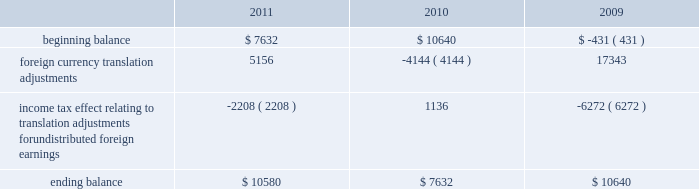The table sets forth the components of foreign currency translation adjustments for fiscal 2011 , 2010 and 2009 ( in thousands ) : beginning balance foreign currency translation adjustments income tax effect relating to translation adjustments for undistributed foreign earnings ending balance $ 7632 ( 2208 ) $ 10580 $ 10640 ( 4144 ) $ 7632 $ ( 431 ) 17343 ( 6272 ) $ 10640 stock repurchase program to facilitate our stock repurchase program , designed to return value to our stockholders and minimize dilution from stock issuances , we repurchase shares in the open market and also enter into structured repurchase agreements with third-parties .
Authorization to repurchase shares to cover on-going dilution was not subject to expiration .
However , this repurchase program was limited to covering net dilution from stock issuances and was subject to business conditions and cash flow requirements as determined by our board of directors from time to time .
During the third quarter of fiscal 2010 , our board of directors approved an amendment to our stock repurchase program authorized in april 2007 from a non-expiring share-based authority to a time-constrained dollar-based authority .
As part of this amendment , the board of directors granted authority to repurchase up to $ 1.6 billion in common stock through the end of fiscal 2012 .
This amended program did not affect the $ 250.0 million structured stock repurchase agreement entered into during march 2010 .
As of december 3 , 2010 , no prepayments remain under that agreement .
During fiscal 2011 , 2010 and 2009 , we entered into several structured repurchase agreements with large financial institutions , whereupon we provided the financial institutions with prepayments totaling $ 695.0 million , $ 850.0 million and $ 350.0 million , respectively .
Of the $ 850.0 million of prepayments during fiscal 2010 , $ 250.0 million was under the stock repurchase program prior to the program amendment and the remaining $ 600.0 million was under the amended $ 1.6 billion time-constrained dollar- based authority .
We enter into these agreements in order to take advantage of repurchasing shares at a guaranteed discount to the volume weighted average price ( 201cvwap 201d ) of our common stock over a specified period of time .
We only enter into such transactions when the discount that we receive is higher than the foregone return on our cash prepayments to the financial institutions .
There were no explicit commissions or fees on these structured repurchases .
Under the terms of the agreements , there is no requirement for the financial institutions to return any portion of the prepayment to us .
The financial institutions agree to deliver shares to us at monthly intervals during the contract term .
The parameters used to calculate the number of shares deliverable are : the total notional amount of the contract , the number of trading days in the contract , the number of trading days in the interval and the average vwap of our stock during the interval less the agreed upon discount .
During fiscal 2011 , we repurchased approximately 21.8 million shares at an average price of $ 31.81 through structured repurchase agreements entered into during fiscal 2011 .
During fiscal 2010 , we repurchased approximately 31.2 million shares at an average price of $ 29.19 through structured repurchase agreements entered into during fiscal 2009 and fiscal 2010 .
During fiscal 2009 , we repurchased approximately 15.2 million shares at an average price per share of $ 27.89 through structured repurchase agreements entered into during fiscal 2008 and fiscal 2009 .
For fiscal 2011 , 2010 and 2009 , the prepayments were classified as treasury stock on our consolidated balance sheets at the payment date , though only shares physically delivered to us by december 2 , 2011 , december 3 , 2010 and november 27 , 2009 were excluded from the computation of earnings per share .
As of december 2 , 2011 and december 3 , 2010 , no prepayments remained under these agreements .
As of november 27 , 2009 , approximately $ 59.9 million of prepayments remained under these agreements .
Subsequent to december 2 , 2011 , as part of our $ 1.6 billion stock repurchase program , we entered into a structured stock repurchase agreement with a large financial institution whereupon we provided them with a prepayment of $ 80.0 million .
This amount will be classified as treasury stock on our consolidated balance sheets .
Upon completion of the $ 80.0 million stock table of contents adobe systems incorporated notes to consolidated financial statements ( continued ) jarcamo typewritten text .
The following table sets forth the components of foreign currency translation adjustments for fiscal 2011 , 2010 and 2009 ( in thousands ) : beginning balance foreign currency translation adjustments income tax effect relating to translation adjustments for undistributed foreign earnings ending balance $ 7632 ( 2208 ) $ 10580 $ 10640 ( 4144 ) $ 7632 $ ( 431 ) 17343 ( 6272 ) $ 10640 stock repurchase program to facilitate our stock repurchase program , designed to return value to our stockholders and minimize dilution from stock issuances , we repurchase shares in the open market and also enter into structured repurchase agreements with third-parties .
Authorization to repurchase shares to cover on-going dilution was not subject to expiration .
However , this repurchase program was limited to covering net dilution from stock issuances and was subject to business conditions and cash flow requirements as determined by our board of directors from time to time .
During the third quarter of fiscal 2010 , our board of directors approved an amendment to our stock repurchase program authorized in april 2007 from a non-expiring share-based authority to a time-constrained dollar-based authority .
As part of this amendment , the board of directors granted authority to repurchase up to $ 1.6 billion in common stock through the end of fiscal 2012 .
This amended program did not affect the $ 250.0 million structured stock repurchase agreement entered into during march 2010 .
As of december 3 , 2010 , no prepayments remain under that agreement .
During fiscal 2011 , 2010 and 2009 , we entered into several structured repurchase agreements with large financial institutions , whereupon we provided the financial institutions with prepayments totaling $ 695.0 million , $ 850.0 million and $ 350.0 million , respectively .
Of the $ 850.0 million of prepayments during fiscal 2010 , $ 250.0 million was under the stock repurchase program prior to the program amendment and the remaining $ 600.0 million was under the amended $ 1.6 billion time-constrained dollar- based authority .
We enter into these agreements in order to take advantage of repurchasing shares at a guaranteed discount to the volume weighted average price ( 201cvwap 201d ) of our common stock over a specified period of time .
We only enter into such transactions when the discount that we receive is higher than the foregone return on our cash prepayments to the financial institutions .
There were no explicit commissions or fees on these structured repurchases .
Under the terms of the agreements , there is no requirement for the financial institutions to return any portion of the prepayment to us .
The financial institutions agree to deliver shares to us at monthly intervals during the contract term .
The parameters used to calculate the number of shares deliverable are : the total notional amount of the contract , the number of trading days in the contract , the number of trading days in the interval and the average vwap of our stock during the interval less the agreed upon discount .
During fiscal 2011 , we repurchased approximately 21.8 million shares at an average price of $ 31.81 through structured repurchase agreements entered into during fiscal 2011 .
During fiscal 2010 , we repurchased approximately 31.2 million shares at an average price of $ 29.19 through structured repurchase agreements entered into during fiscal 2009 and fiscal 2010 .
During fiscal 2009 , we repurchased approximately 15.2 million shares at an average price per share of $ 27.89 through structured repurchase agreements entered into during fiscal 2008 and fiscal 2009 .
For fiscal 2011 , 2010 and 2009 , the prepayments were classified as treasury stock on our consolidated balance sheets at the payment date , though only shares physically delivered to us by december 2 , 2011 , december 3 , 2010 and november 27 , 2009 were excluded from the computation of earnings per share .
As of december 2 , 2011 and december 3 , 2010 , no prepayments remained under these agreements .
As of november 27 , 2009 , approximately $ 59.9 million of prepayments remained under these agreements .
Subsequent to december 2 , 2011 , as part of our $ 1.6 billion stock repurchase program , we entered into a structured stock repurchase agreement with a large financial institution whereupon we provided them with a prepayment of $ 80.0 million .
This amount will be classified as treasury stock on our consolidated balance sheets .
Upon completion of the $ 80.0 million stock table of contents adobe systems incorporated notes to consolidated financial statements ( continued ) jarcamo typewritten text .
For the $ 1.6 billion stock repurchase program , what percentage was the structured stock repurchase agreement with a large financial institution? 
Rationale: converted the billions to millions
Computations: (80.0 / (1.6 * 1000))
Answer: 0.05. 